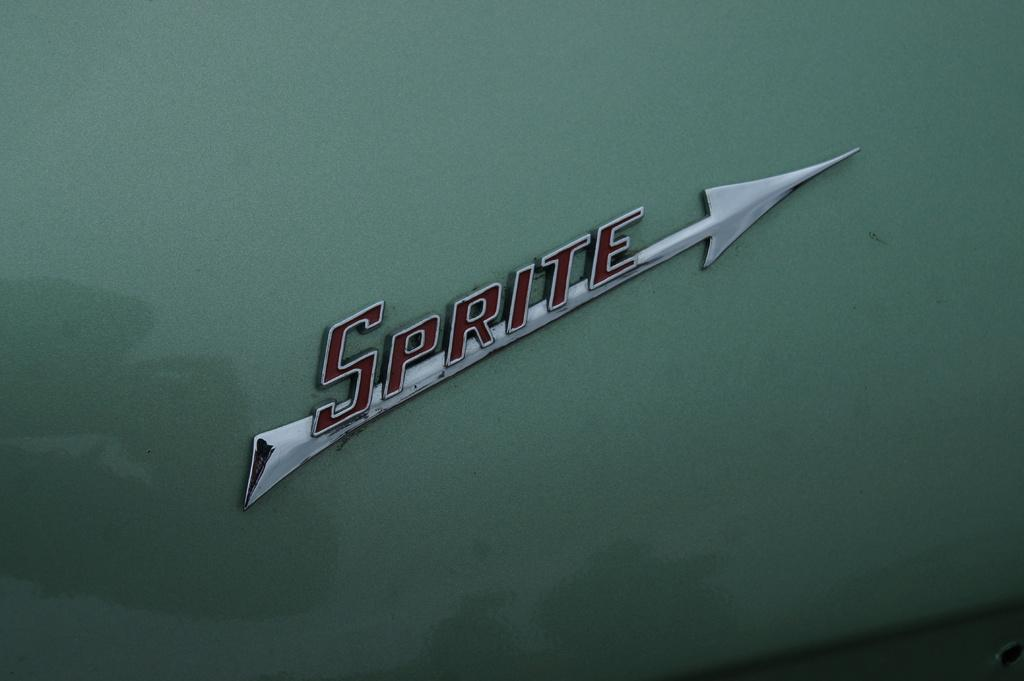What can be seen on the object in the image? There is text on an object in the image. How many cows are grazing in the background of the image? There are no cows present in the image; it only features an object with text on it. What type of brake is visible on the object in the image? There is no brake visible on the object in the image; it only features text. 